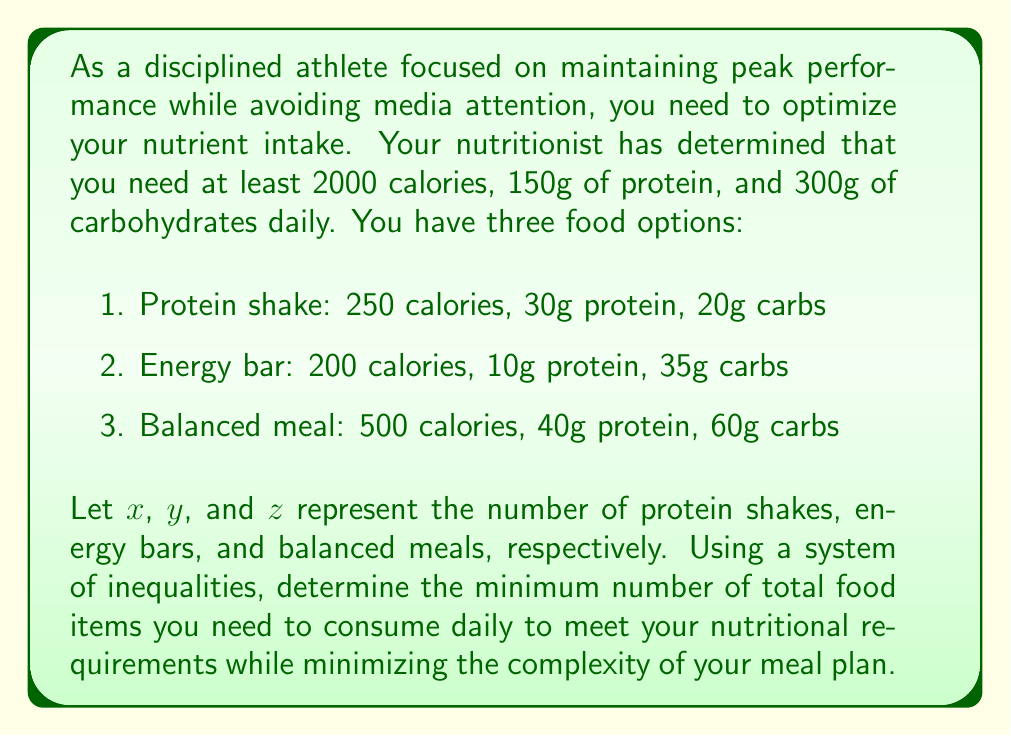Show me your answer to this math problem. Let's approach this step-by-step:

1) First, we need to set up our system of inequalities based on the nutritional requirements:

   Calories: $250x + 200y + 500z \geq 2000$
   Protein: $30x + 10y + 40z \geq 150$
   Carbs: $20x + 35y + 60z \geq 300$

2) We also need to ensure that $x$, $y$, and $z$ are non-negative integers:

   $x \geq 0$, $y \geq 0$, $z \geq 0$
   $x$, $y$, $z$ are integers

3) Our objective is to minimize the total number of food items, which is represented by $x + y + z$.

4) This is an integer linear programming problem. While it can be solved using advanced techniques, we can approach it systematically for this specific case.

5) Let's start by considering balanced meals ($z$) as they provide the most balanced nutrition. If we consume 4 balanced meals:

   $500 \cdot 4 = 2000$ calories
   $40 \cdot 4 = 160$ g protein
   $60 \cdot 4 = 240$ g carbs

   This meets the calorie and protein requirements but falls short on carbs.

6) We need 60g more carbs. An energy bar provides 35g of carbs, so two energy bars will suffice and even exceed the carb requirement slightly.

7) Therefore, a solution that meets all requirements is:
   $x = 0$ (protein shakes)
   $y = 2$ (energy bars)
   $z = 4$ (balanced meals)

8) This solution uses a total of 6 food items $(0 + 2 + 4 = 6)$.

9) We can verify that this solution satisfies all inequalities:

   Calories: $250(0) + 200(2) + 500(4) = 2400 \geq 2000$
   Protein: $30(0) + 10(2) + 40(4) = 180 \geq 150$
   Carbs: $20(0) + 35(2) + 60(4) = 310 \geq 300$

10) While there might be other solutions that also satisfy the inequalities, this solution minimizes the total number of food items while meeting all nutritional requirements.
Answer: The minimum number of food items needed daily is 6, consisting of 0 protein shakes, 2 energy bars, and 4 balanced meals. This can be represented as the solution $(x, y, z) = (0, 2, 4)$. 